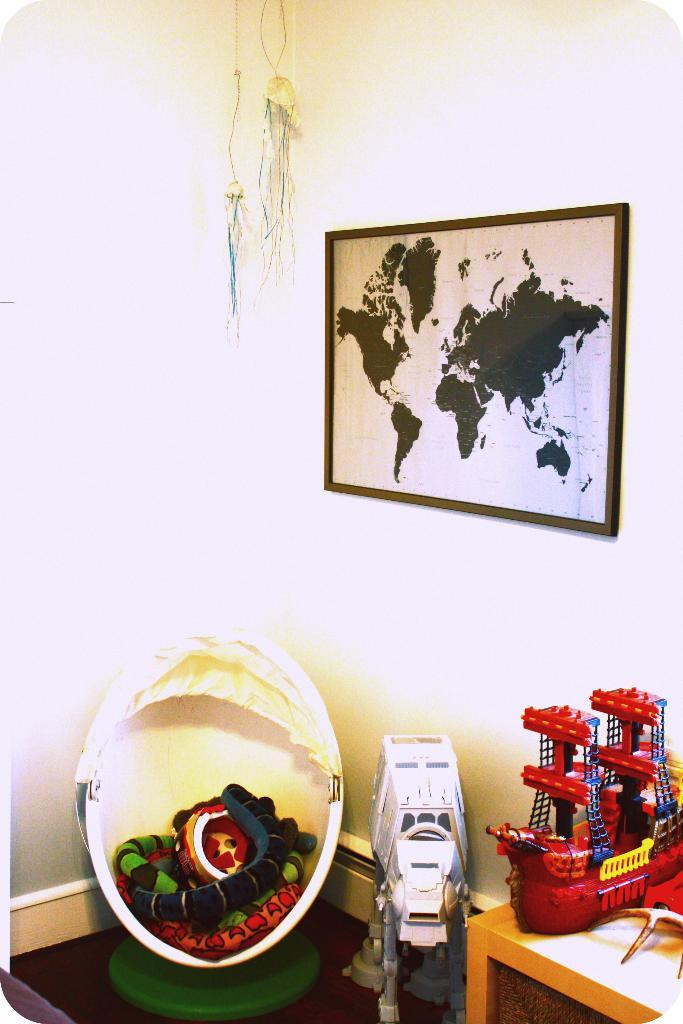What is hanging on the wall in the image? There is a frame on the wall in the image. What object can be seen on a table in the image? There is a toy on a table in the image. Is there a mask covering the toy on the table in the image? There is no mask present in the image, and the toy on the table is not covered by any object. 